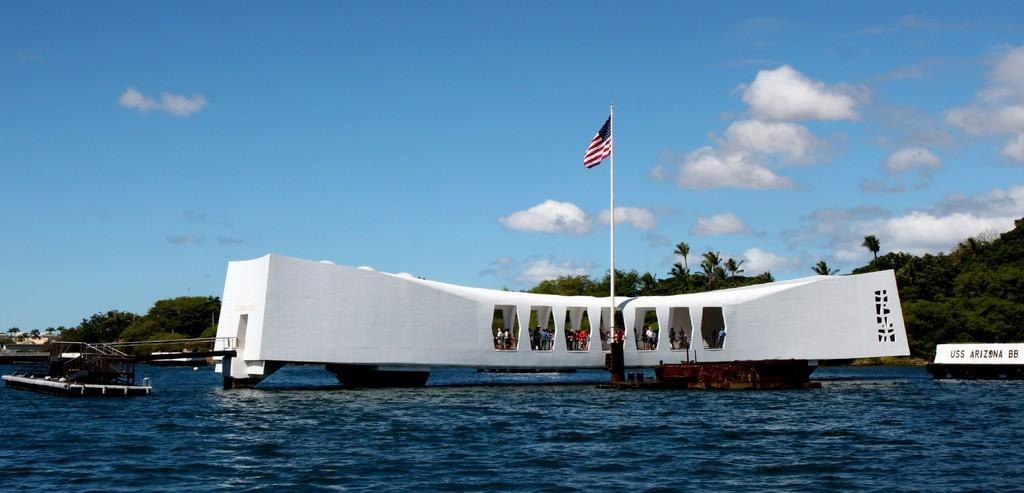<image>
Provide a brief description of the given image. An American flag at the USS Arizona memorial. 